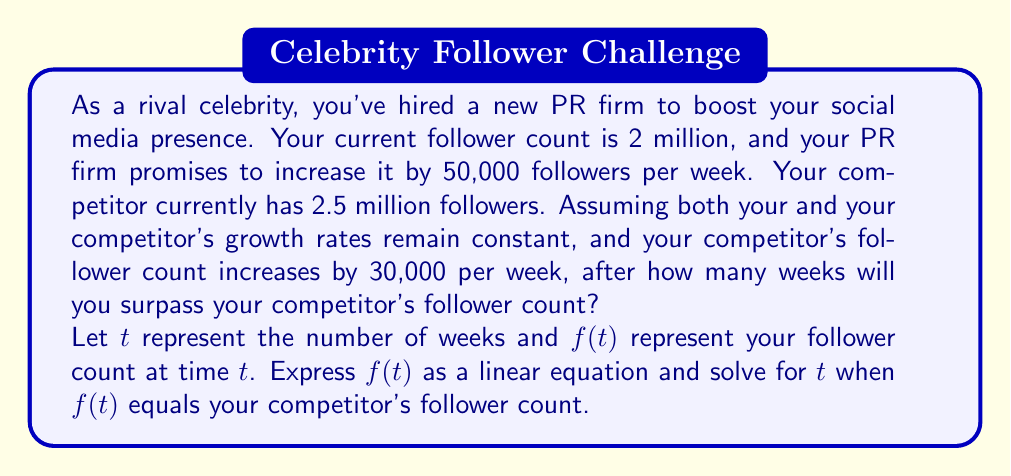Give your solution to this math problem. Let's approach this step-by-step:

1) First, let's express your follower count as a function of time:
   $f(t) = 2,000,000 + 50,000t$

2) Your competitor's follower count can be expressed as:
   $g(t) = 2,500,000 + 30,000t$

3) To find when you'll surpass your competitor, we need to solve the equation:
   $f(t) = g(t)$

4) Substituting the functions:
   $2,000,000 + 50,000t = 2,500,000 + 30,000t$

5) Simplify:
   $50,000t - 30,000t = 2,500,000 - 2,000,000$
   $20,000t = 500,000$

6) Solve for $t$:
   $t = \frac{500,000}{20,000} = 25$

Therefore, after 25 weeks, your follower count will equal your competitor's. To surpass them, you'll need the next week, which is the 26th week.

To verify:
Your followers at week 26: $f(26) = 2,000,000 + 50,000(26) = 3,300,000$
Competitor's followers at week 26: $g(26) = 2,500,000 + 30,000(26) = 3,280,000$

Indeed, at week 26, you have surpassed your competitor.
Answer: You will surpass your competitor's follower count after 26 weeks. 